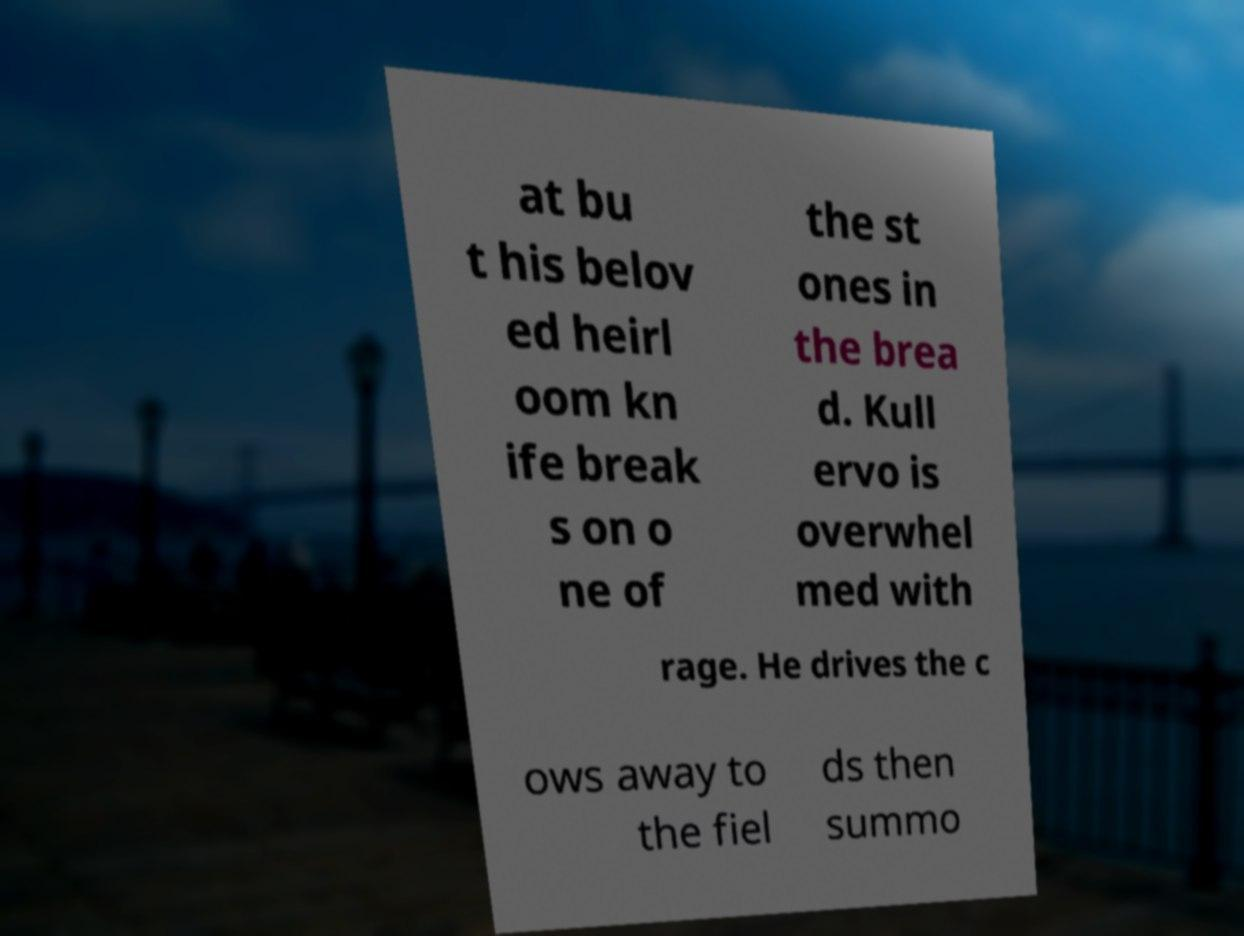What messages or text are displayed in this image? I need them in a readable, typed format. at bu t his belov ed heirl oom kn ife break s on o ne of the st ones in the brea d. Kull ervo is overwhel med with rage. He drives the c ows away to the fiel ds then summo 